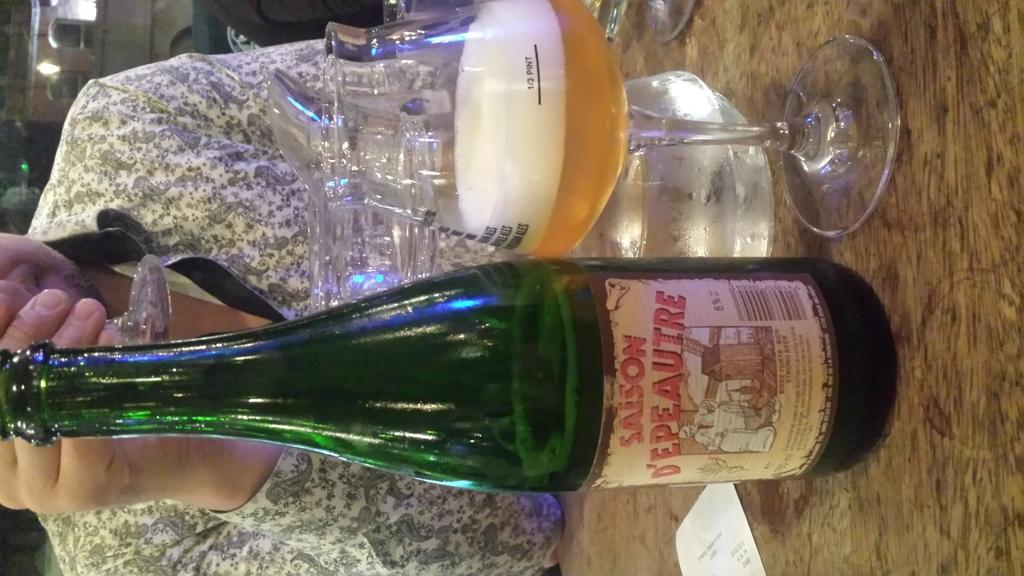What is the main subject of the image? There is a person in the image. What is the person doing in the image? The person is sitting in front of a table. What is the person holding in his right hand? The person is holding a wine glass with his right hand. What other beverages are present in front of the person? There is a beer bottle and a beer glass in front of the person. Can you see a pickle on the table in the image? There is no pickle present on the table in the image. What type of frog is sitting next to the person in the image? There is no frog present in the image; only the person and the beverages are visible. 